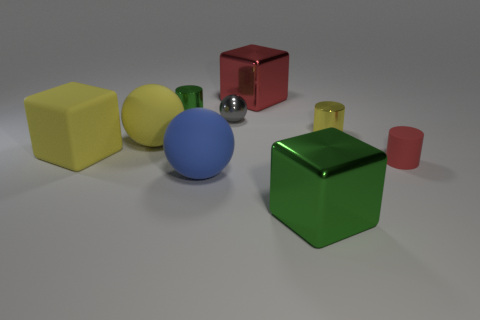Is the number of red matte cylinders that are behind the blue sphere less than the number of tiny cyan rubber cylinders?
Your answer should be very brief. No. Are there any other things that are the same shape as the tiny green thing?
Offer a very short reply. Yes. There is a object that is behind the small green object; what is its shape?
Offer a terse response. Cube. What is the shape of the small yellow metallic object that is in front of the metal thing that is behind the green metal object left of the red block?
Keep it short and to the point. Cylinder. What number of things are either purple metallic cylinders or green metal things?
Your answer should be compact. 2. Does the red thing that is on the left side of the tiny yellow object have the same shape as the green metallic object that is behind the gray ball?
Keep it short and to the point. No. What number of rubber things are behind the blue rubber object and on the left side of the big red thing?
Offer a terse response. 2. What number of other things are the same size as the red block?
Ensure brevity in your answer.  4. There is a large thing that is both in front of the tiny gray thing and right of the blue ball; what is it made of?
Your response must be concise. Metal. There is a big rubber cube; is it the same color as the block that is behind the gray ball?
Provide a succinct answer. No. 